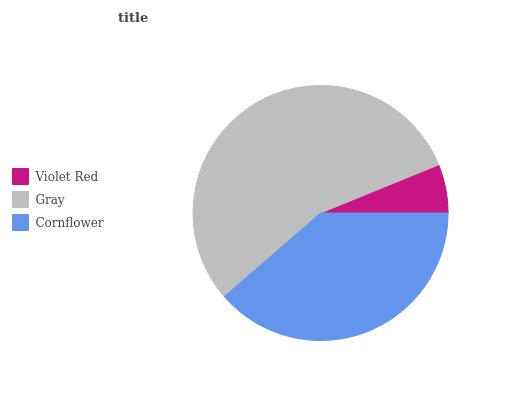Is Violet Red the minimum?
Answer yes or no. Yes. Is Gray the maximum?
Answer yes or no. Yes. Is Cornflower the minimum?
Answer yes or no. No. Is Cornflower the maximum?
Answer yes or no. No. Is Gray greater than Cornflower?
Answer yes or no. Yes. Is Cornflower less than Gray?
Answer yes or no. Yes. Is Cornflower greater than Gray?
Answer yes or no. No. Is Gray less than Cornflower?
Answer yes or no. No. Is Cornflower the high median?
Answer yes or no. Yes. Is Cornflower the low median?
Answer yes or no. Yes. Is Gray the high median?
Answer yes or no. No. Is Gray the low median?
Answer yes or no. No. 